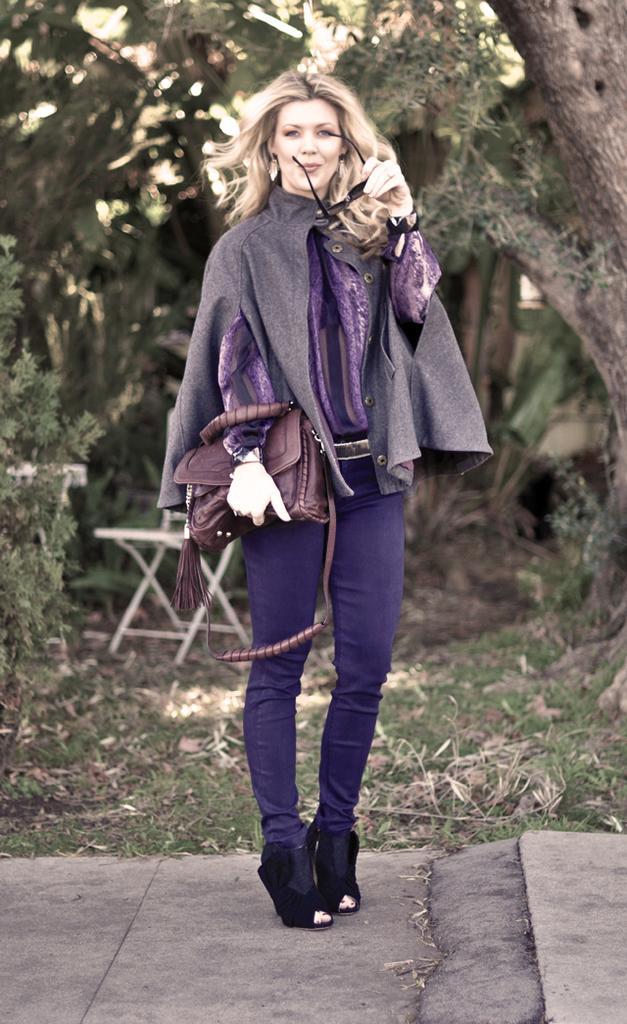Can you describe this image briefly? In this picture there is a girl wearing a gray color jacket and holding a brown color handbag on her left hand and holding a spectacles on her right hand and back side of her there are some trees and on the middle there is a chair and she is standing on the floor. And she is smiling. and left side there is a planet visible. 